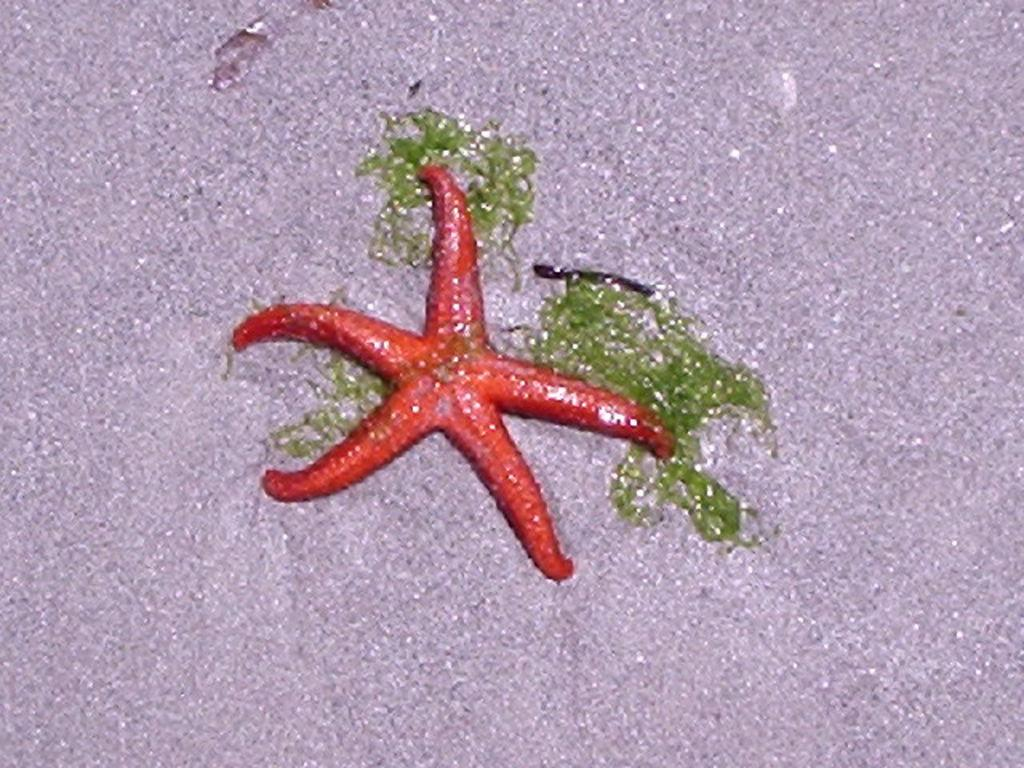What type of marine life can be seen in the image? There are starfish in the image. What else is present on the surface in the image? There is algae in the image. Are the starfish and algae submerged or on the surface? Both starfish and algae are on the surface in the image. How many beds are visible in the image? There are no beds present in the image; it features starfish and algae on a surface. What event related to death or birth is taking place in the image? There is no event related to death or birth present in the image; it features starfish and algae on a surface. 